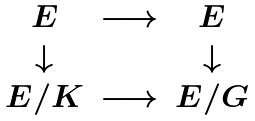<formula> <loc_0><loc_0><loc_500><loc_500>\begin{matrix} E & \longrightarrow & E \\ \downarrow & \quad & \downarrow \\ E / K & \longrightarrow & E / G \end{matrix}</formula> 